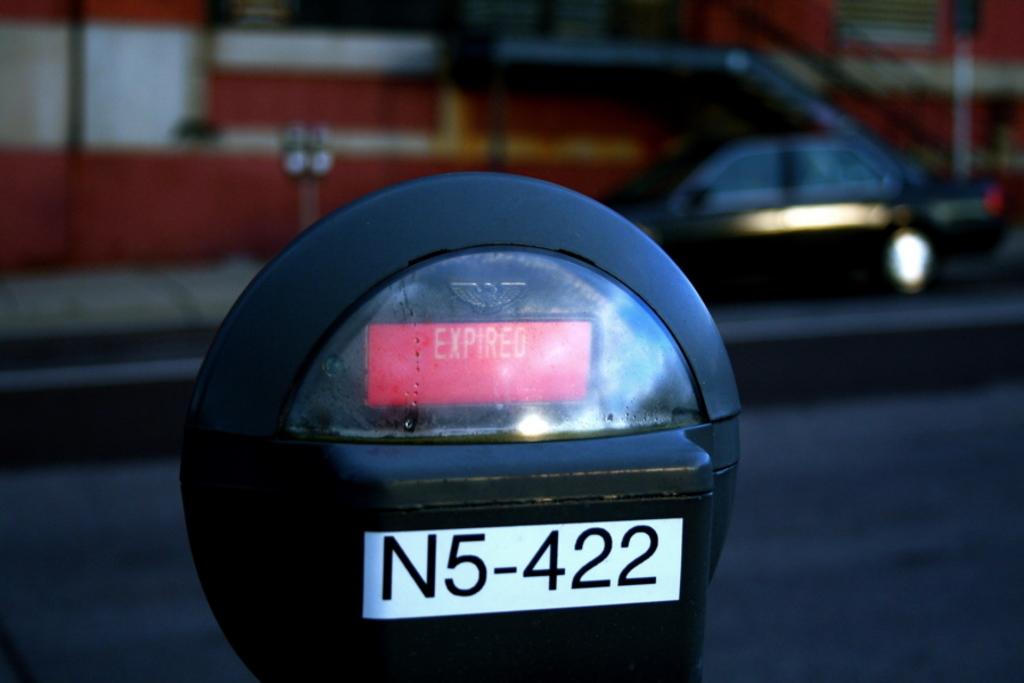What does it say in the red box?
Offer a very short reply. Expired. What is the letter and numbering of this parking meter?
Your answer should be compact. N5-422. 